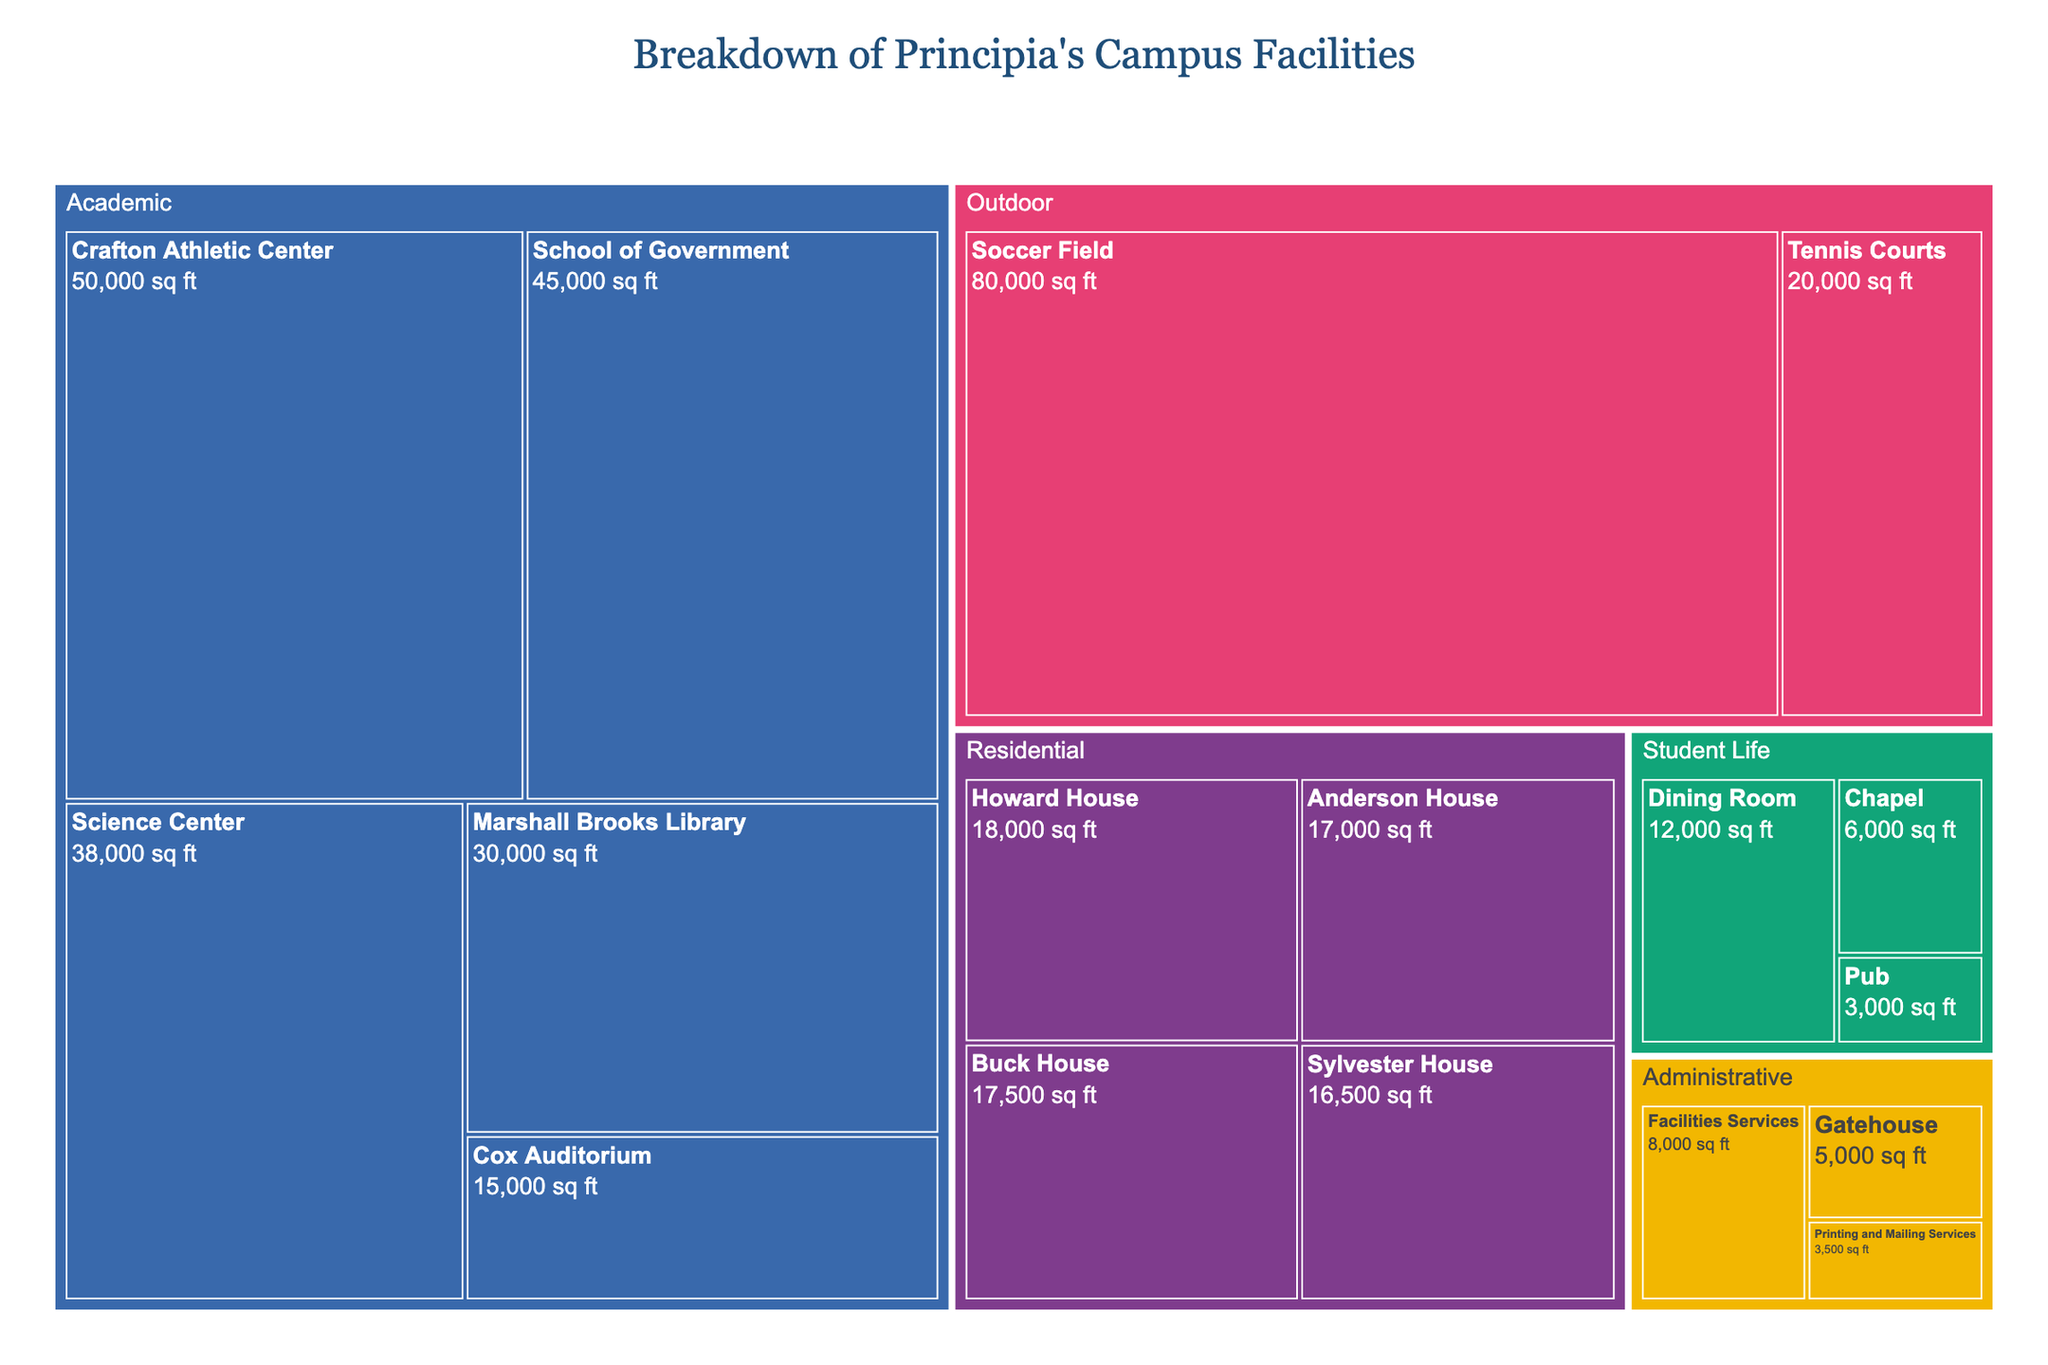Which facility has the largest square footage? The largest square footage can be identified by checking the largest area of the treemap. The "Soccer Field" under the "Outdoor" category occupies the largest space with 80,000 sq ft.
Answer: Soccer Field What is the total square footage of all residential facilities? To find the total, sum the square footage of all residential facilities: Howard House (18,000) + Buck House (17,500) + Anderson House (17,000) + Sylvester House (16,500) = 69,000 sq ft.
Answer: 69,000 sq ft Which category has the most facilities? Count the number of subcategories in each category visually. "Academic" has the most facilities with five subcategories: School of Government, Science Center, Cox Auditorium, Marshall Brooks Library, and Crafton Athletic Center.
Answer: Academic What is the second largest facility in the "Academic" category? In the "Academic" category, after comparing the sizes visually, the second largest is the Science Center with a square footage of 38,000 sq ft, right after Crafton Athletic Center.
Answer: Science Center How does the square footage of the "Dining Room" compare to the "Pub"? The "Dining Room" has a square footage of 12,000, while the "Pub" has 3,000. To compare, 12,000 is greater than 3,000, meaning the "Dining Room" is 4 times larger than the "Pub".
Answer: Dining Room is larger Which Administrative facility has the smallest square footage? By identifying the subcategory with the smallest area under the "Administrative" category, "Printing and Mailing Services" has the smallest footprint with 3,500 sq ft.
Answer: Printing and Mailing Services What is the combined square footage of "Student Life" facilities? Sum the square footage of the subcategories under "Student Life": Dining Room (12,000) + Pub (3,000) + Chapel (6,000) = 21,000 sq ft.
Answer: 21,000 sq ft What category does “Cox Auditorium” belong to? Observe the grouping of the treemap; "Cox Auditorium" falls under the "Academic" category.
Answer: Academic Which category has the smallest total square footage? By visually comparing the total area occupied by each category, "Administrative" has the smallest combined square footage: Gatehouse (5,000) + Printing and Mailing Services (3,500) + Facilities Services (8,000) = 16,500 sq ft.
Answer: Administrative How does the total square footage of "Outdoor" facilities compare to the "Residential" facilities? Sum the square footage of each: Outdoor (Soccer Field 80,000 + Tennis Courts 20,000 = 100,000) and Residential (69,000). The total for "Outdoor" is considerably larger at 100,000 sq ft compared to 69,000 sq ft for "Residential".
Answer: Outdoor is larger 